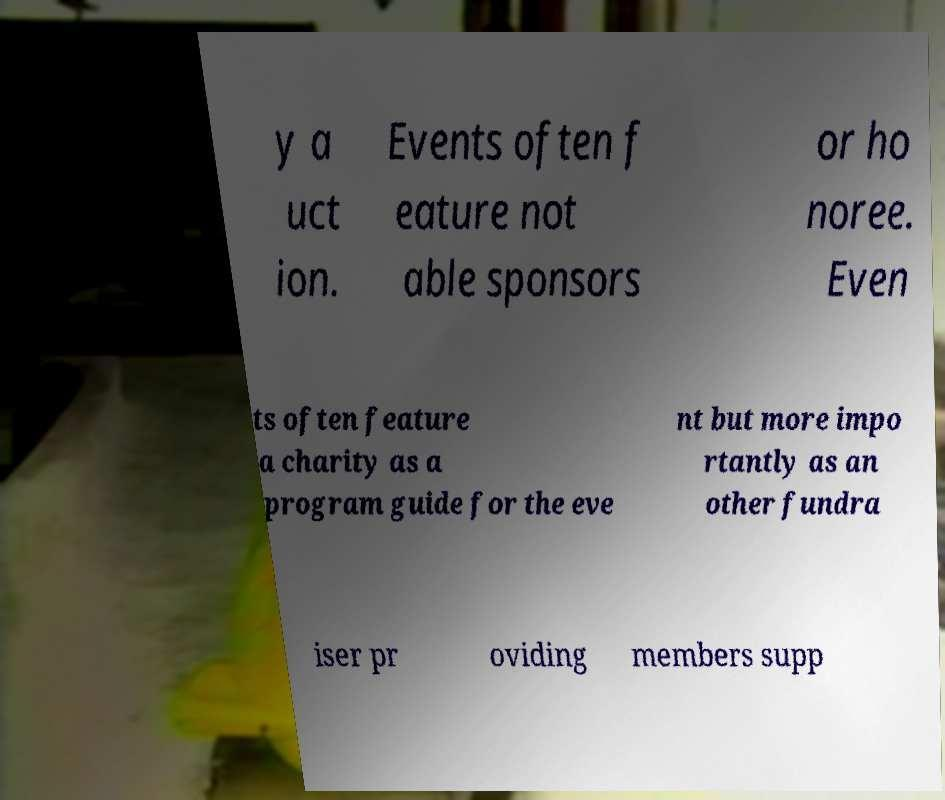There's text embedded in this image that I need extracted. Can you transcribe it verbatim? y a uct ion. Events often f eature not able sponsors or ho noree. Even ts often feature a charity as a program guide for the eve nt but more impo rtantly as an other fundra iser pr oviding members supp 